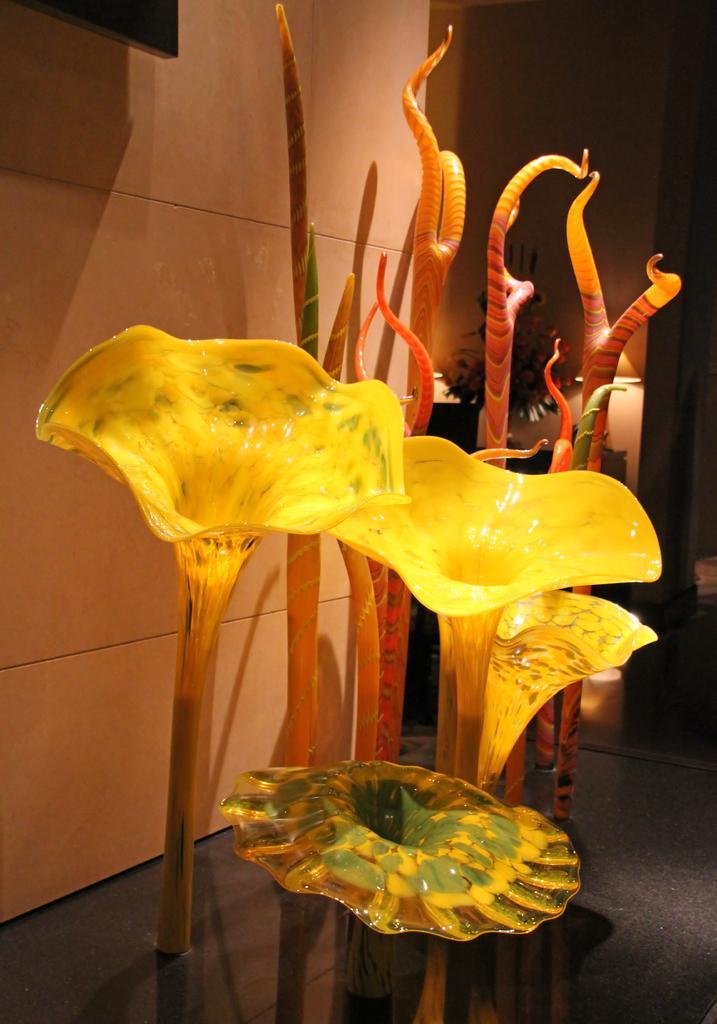Describe this image in one or two sentences. In this picture there are artificial flowers and other objects. In the background there are house plant, desk and lamps. 